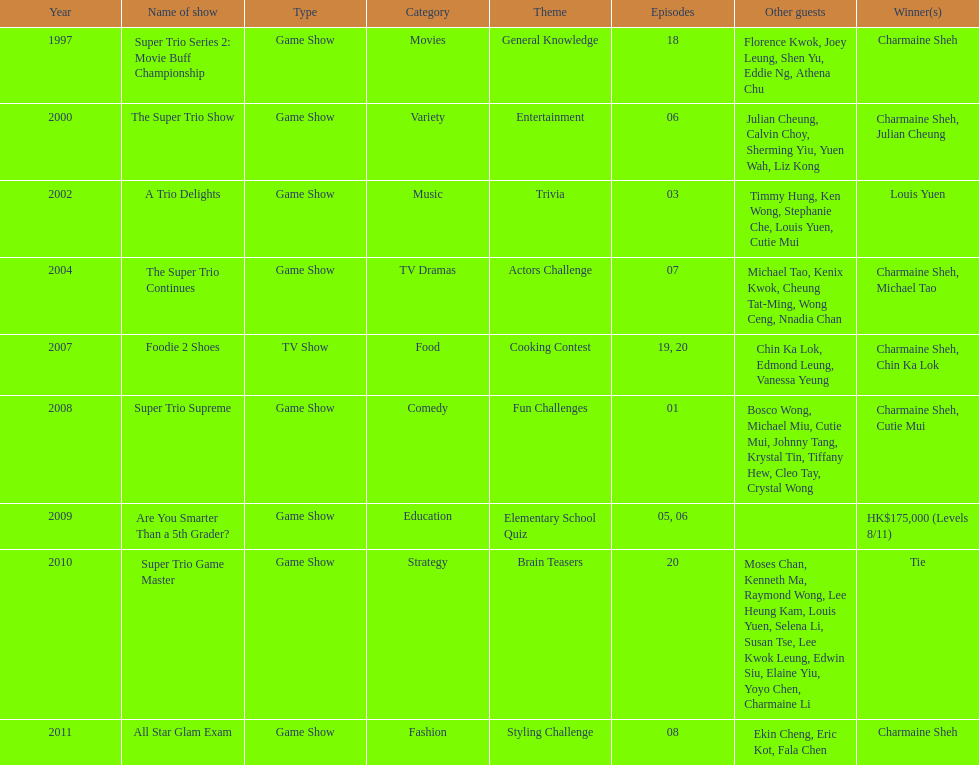How long has it been since chermaine sheh first appeared on a variety show? 17 years. Would you mind parsing the complete table? {'header': ['Year', 'Name of show', 'Type', 'Category', 'Theme', 'Episodes', 'Other guests', 'Winner(s)'], 'rows': [['1997', 'Super Trio Series 2: Movie Buff Championship', 'Game Show', 'Movies', 'General Knowledge', '18', 'Florence Kwok, Joey Leung, Shen Yu, Eddie Ng, Athena Chu', 'Charmaine Sheh'], ['2000', 'The Super Trio Show', 'Game Show', 'Variety', 'Entertainment', '06', 'Julian Cheung, Calvin Choy, Sherming Yiu, Yuen Wah, Liz Kong', 'Charmaine Sheh, Julian Cheung'], ['2002', 'A Trio Delights', 'Game Show', 'Music', 'Trivia', '03', 'Timmy Hung, Ken Wong, Stephanie Che, Louis Yuen, Cutie Mui', 'Louis Yuen'], ['2004', 'The Super Trio Continues', 'Game Show', 'TV Dramas', 'Actors Challenge', '07', 'Michael Tao, Kenix Kwok, Cheung Tat-Ming, Wong Ceng, Nnadia Chan', 'Charmaine Sheh, Michael Tao'], ['2007', 'Foodie 2 Shoes', 'TV Show', 'Food', 'Cooking Contest', '19, 20', 'Chin Ka Lok, Edmond Leung, Vanessa Yeung', 'Charmaine Sheh, Chin Ka Lok'], ['2008', 'Super Trio Supreme', 'Game Show', 'Comedy', 'Fun Challenges', '01', 'Bosco Wong, Michael Miu, Cutie Mui, Johnny Tang, Krystal Tin, Tiffany Hew, Cleo Tay, Crystal Wong', 'Charmaine Sheh, Cutie Mui'], ['2009', 'Are You Smarter Than a 5th Grader?', 'Game Show', 'Education', 'Elementary School Quiz', '05, 06', '', 'HK$175,000 (Levels 8/11)'], ['2010', 'Super Trio Game Master', 'Game Show', 'Strategy', 'Brain Teasers', '20', 'Moses Chan, Kenneth Ma, Raymond Wong, Lee Heung Kam, Louis Yuen, Selena Li, Susan Tse, Lee Kwok Leung, Edwin Siu, Elaine Yiu, Yoyo Chen, Charmaine Li', 'Tie'], ['2011', 'All Star Glam Exam', 'Game Show', 'Fashion', 'Styling Challenge', '08', 'Ekin Cheng, Eric Kot, Fala Chen', 'Charmaine Sheh']]} 